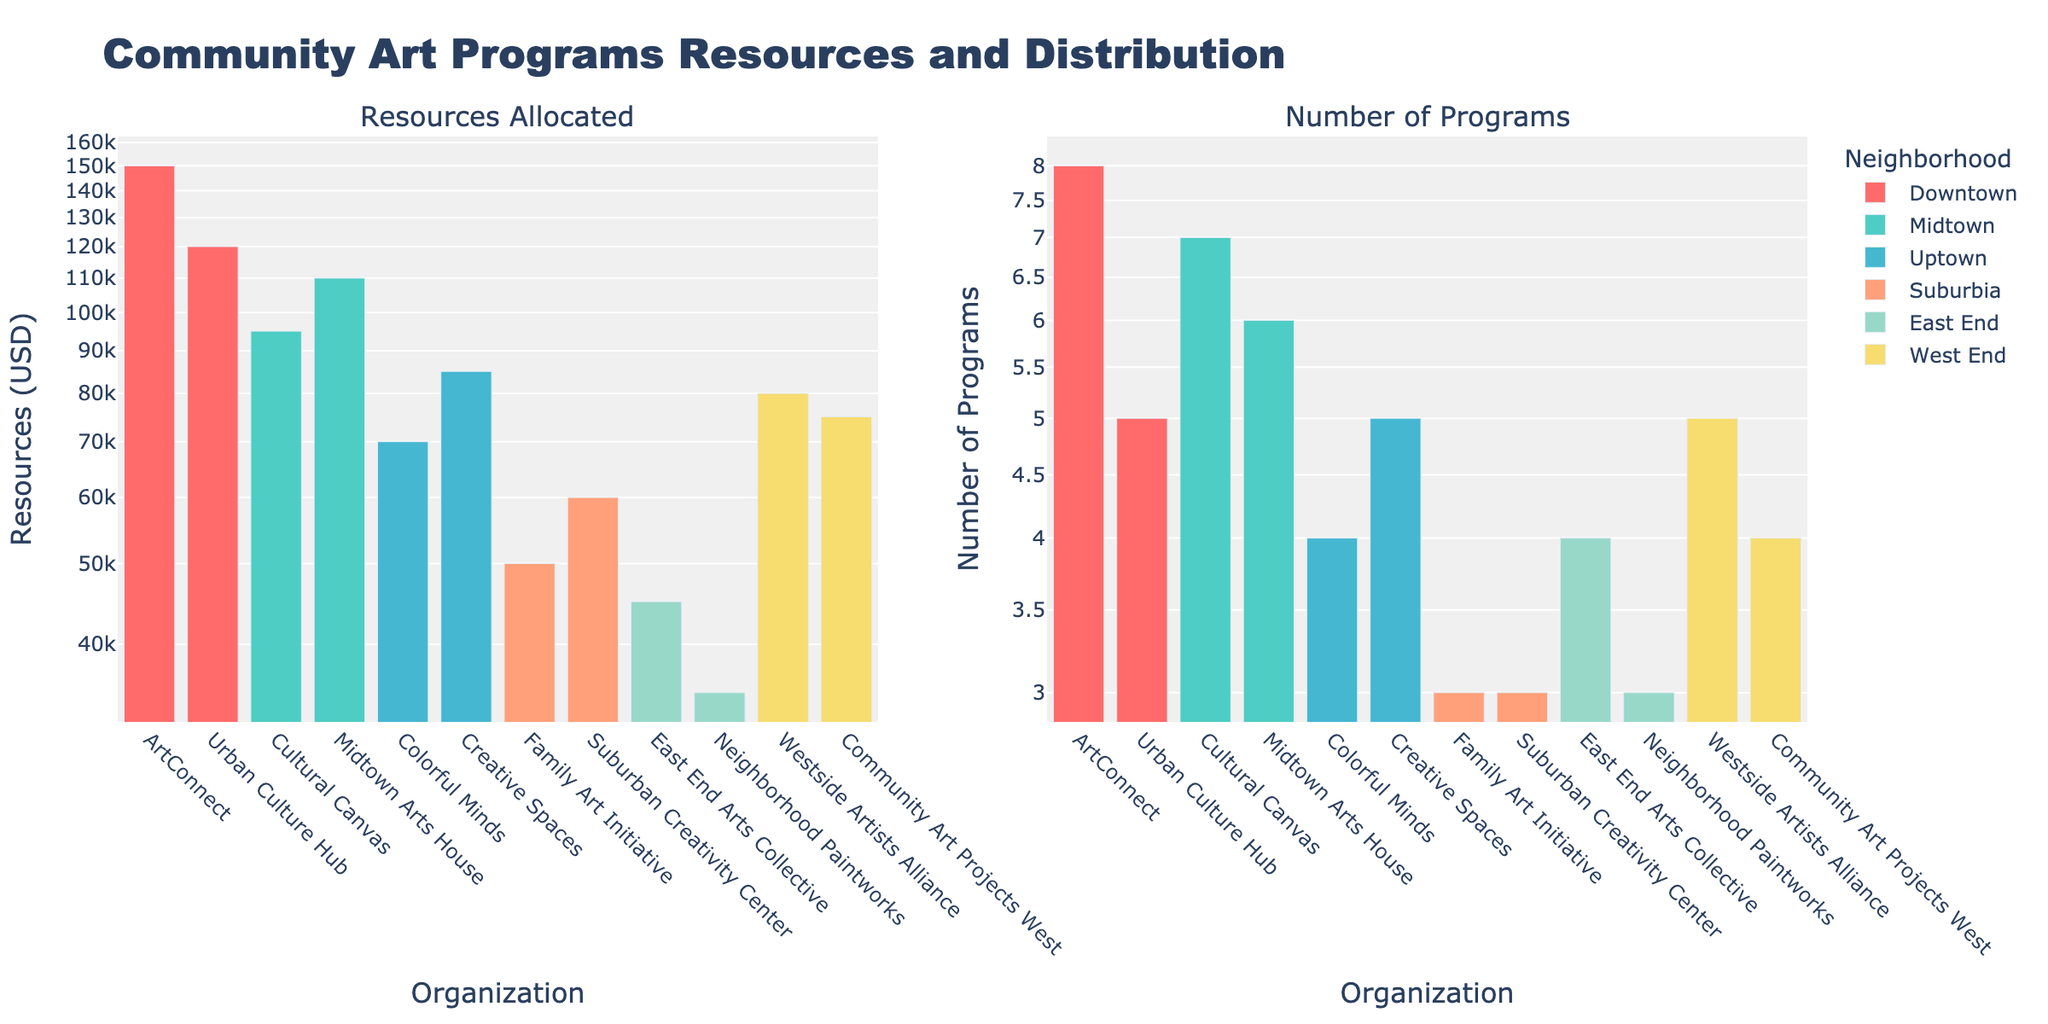Which neighborhood has the highest resources allocated? By examining the "Resources Allocated" subplot, look for the tallest bar on the y-axis in the corresponding neighborhood's color. The tallest bar belongs to Downtown.
Answer: Downtown Which organization in the East End neighborhood received the least amount of resources? To find this, locate the East End neighborhood's bars in the "Resources Allocated" subplot. Compare the heights of East End Arts Collective and Neighborhood Paintworks. Neighborhood Paintworks is shorter.
Answer: Neighborhood Paintworks How many programs does Urban Culture Hub offer in Downtown? Identify the bar representing Urban Culture Hub in the "Number of Programs" subplot for Downtown. Read the value from the y-axis.
Answer: 5 Which neighborhood has more programs overall, Midtown or Uptown? Sum the number of programs for all organizations in each neighborhood from the "Number of Programs" subplot. Midtown has Cultural Canvas (7) + Midtown Arts House (6) = 13; Uptown has Colorful Minds (4) + Creative Spaces (5) = 9. Midtown has more programs.
Answer: Midtown What is the total amount of resources allocated in Suburbia? Add the resources allocated to Family Art Initiative and Suburban Creativity Center in Suburbia from the "Resources Allocated" subplot. That's $50,000 + $60,000 = $110,000.
Answer: $110,000 Which organization has the most programs in the West End? In the "Number of Programs" subplot, compare the bars for Westside Artists Alliance and Community Art Projects West. Westside Artists Alliance is higher.
Answer: Westside Artists Alliance Compare the resources allocated between ArtConnect in Downtown and Cultural Canvas in Midtown. Which one has more? Find the bars for ArtConnect in Downtown and Cultural Canvas in Midtown in the "Resources Allocated" subplot. Compare their heights. ArtConnect is taller.
Answer: ArtConnect If the total number of programs in East End increases by 2, what will be the new total? First, find the existing number of programs in East End by summing both organizations' bars from the "Number of Programs" subplot: East End Arts Collective (4) + Neighborhood Paintworks (3) = 7. Adding 2 results in 7 + 2 = 9.
Answer: 9 Which neighborhood has the lowest total resources allocated? Compare the sum of resources for each neighborhood from the "Resources Allocated" subplot. East End has the lowest with East End Arts Collective ($45,000) + Neighborhood Paintworks ($35,000) = $80,000.
Answer: East End 